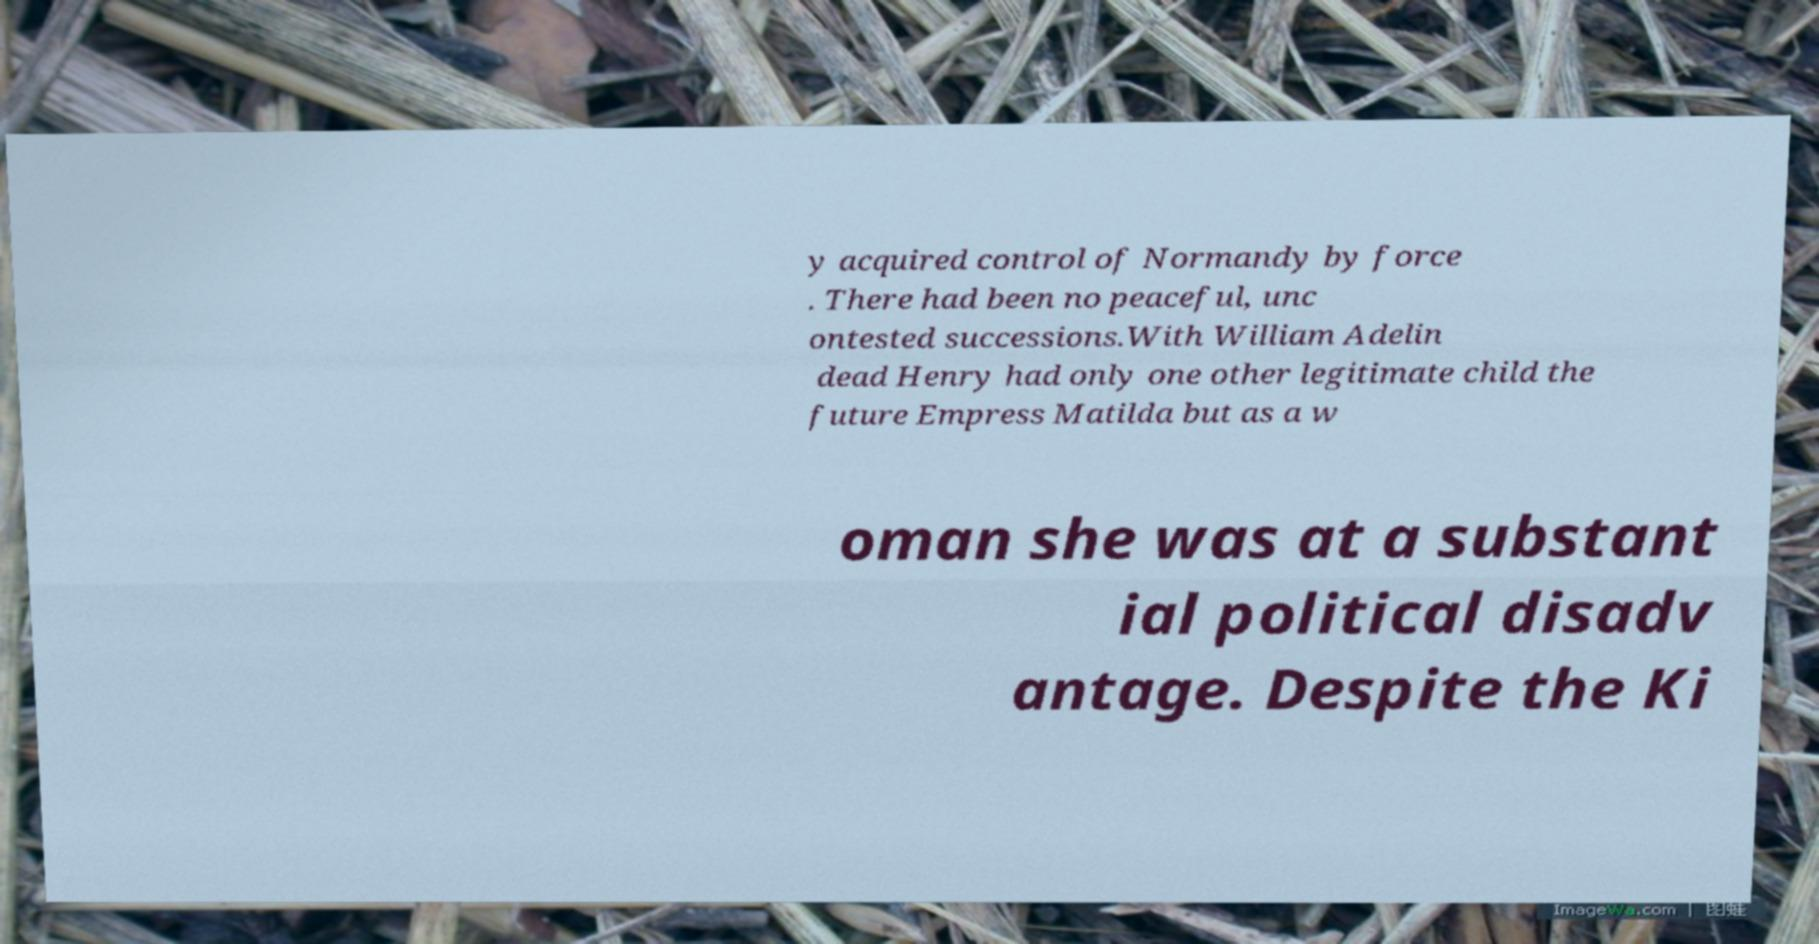There's text embedded in this image that I need extracted. Can you transcribe it verbatim? y acquired control of Normandy by force . There had been no peaceful, unc ontested successions.With William Adelin dead Henry had only one other legitimate child the future Empress Matilda but as a w oman she was at a substant ial political disadv antage. Despite the Ki 